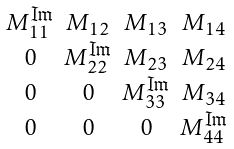Convert formula to latex. <formula><loc_0><loc_0><loc_500><loc_500>\begin{smallmatrix} \\ M _ { 1 1 } ^ { \Im } & M _ { 1 2 } & M _ { 1 3 } & M _ { 1 4 } \\ 0 & M _ { 2 2 } ^ { \Im } & M _ { 2 3 } & M _ { 2 4 } \\ 0 & 0 & M _ { 3 3 } ^ { \Im } & M _ { 3 4 } \\ 0 & 0 & 0 & M _ { 4 4 } ^ { \Im } \\ \end{smallmatrix}</formula> 